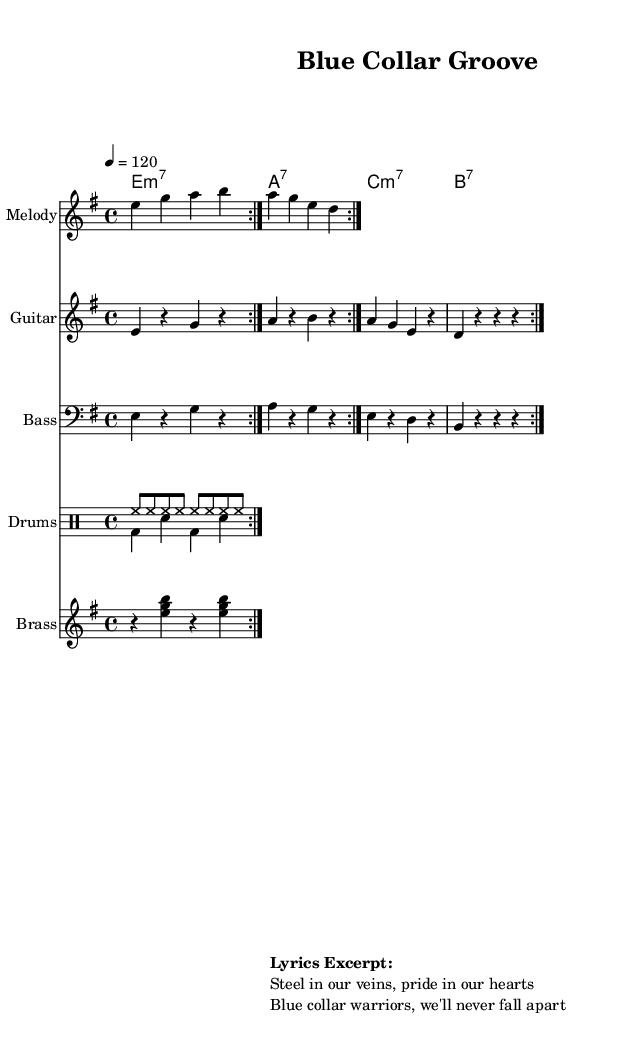What is the key signature of this music? The key signature is E minor, which has one sharp (F#). This can be identified at the beginning of the sheet music where the key is stated.
Answer: E minor What is the time signature of this piece? The time signature is 4/4, which indicates each measure has four beats, and the quarter note receives one beat. This can be seen at the start of the sheet music next to the key signature.
Answer: 4/4 What is the tempo marking of the piece? The tempo is marked as quarter note equals 120, meaning there should be 120 quarter notes played in one minute. This is found in the tempo indication at the top of the score.
Answer: 120 How many measures are repeated in the melody section? The melody section has two measures repeated, indicated by the "repeat volta 2" mark which specifies to play the specified measures twice before moving on.
Answer: 2 What is the instrument designated for the melody line? The melody line is designated for a staff titled “Melody,” which is specified under the staff's name on the sheet music.
Answer: Melody What type of groove does the drum pattern illustrate in this funk track? The drum pattern demonstrates a "backbeat" groove with hi-hat and bass drum interplay, typical of funk music. This can be deduced by analyzing the rhythmic structure where the snare hits on the 2nd and 4th beats.
Answer: Backbeat What is an example of a lyrical theme suggested in the music? The lyrics excerpt mentions "blue collar warriors," reflecting a theme of pride and resilience among workers. This theme is outlined within the "Lyrics Excerpt" section on the sheet.
Answer: Blue collar warriors 